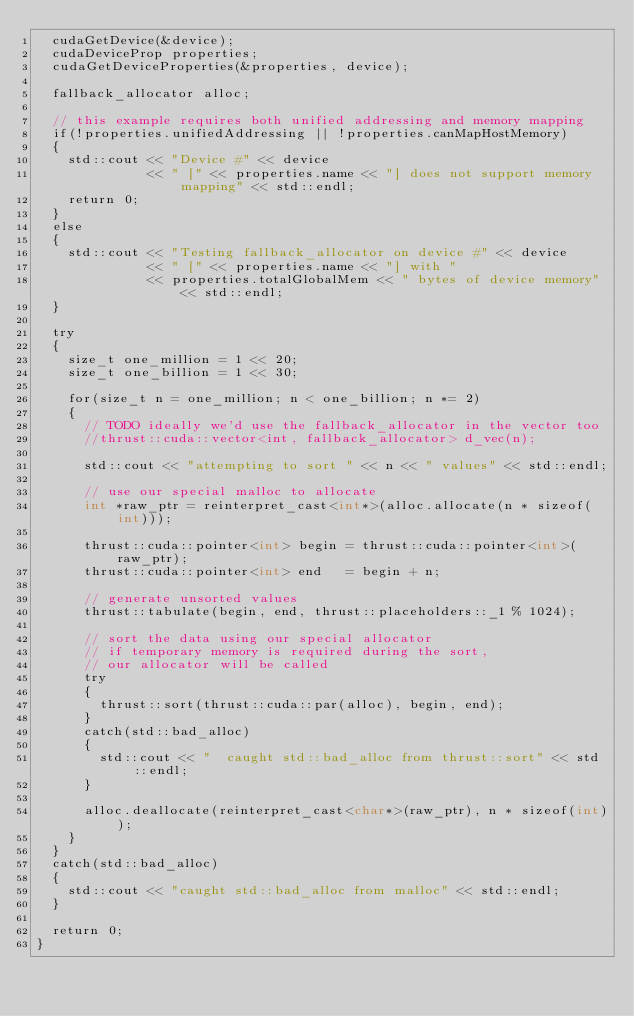<code> <loc_0><loc_0><loc_500><loc_500><_Cuda_>  cudaGetDevice(&device);
  cudaDeviceProp properties;
  cudaGetDeviceProperties(&properties, device);

  fallback_allocator alloc;

  // this example requires both unified addressing and memory mapping
  if(!properties.unifiedAddressing || !properties.canMapHostMemory)
  {
    std::cout << "Device #" << device 
              << " [" << properties.name << "] does not support memory mapping" << std::endl;
    return 0;
  }
  else
  {
    std::cout << "Testing fallback_allocator on device #" << device 
              << " [" << properties.name << "] with " 
              << properties.totalGlobalMem << " bytes of device memory" << std::endl;
  }

  try
  {
    size_t one_million = 1 << 20;
    size_t one_billion = 1 << 30;

    for(size_t n = one_million; n < one_billion; n *= 2)
    {
      // TODO ideally we'd use the fallback_allocator in the vector too
      //thrust::cuda::vector<int, fallback_allocator> d_vec(n);

      std::cout << "attempting to sort " << n << " values" << std::endl;

      // use our special malloc to allocate
      int *raw_ptr = reinterpret_cast<int*>(alloc.allocate(n * sizeof(int)));

      thrust::cuda::pointer<int> begin = thrust::cuda::pointer<int>(raw_ptr);
      thrust::cuda::pointer<int> end   = begin + n;

      // generate unsorted values
      thrust::tabulate(begin, end, thrust::placeholders::_1 % 1024);

      // sort the data using our special allocator
      // if temporary memory is required during the sort,
      // our allocator will be called
      try
      {
        thrust::sort(thrust::cuda::par(alloc), begin, end);
      }
      catch(std::bad_alloc)
      {
        std::cout << "  caught std::bad_alloc from thrust::sort" << std::endl;
      }

      alloc.deallocate(reinterpret_cast<char*>(raw_ptr), n * sizeof(int));
    }
  }
  catch(std::bad_alloc)
  {
    std::cout << "caught std::bad_alloc from malloc" << std::endl;
  }

  return 0;
}

</code> 